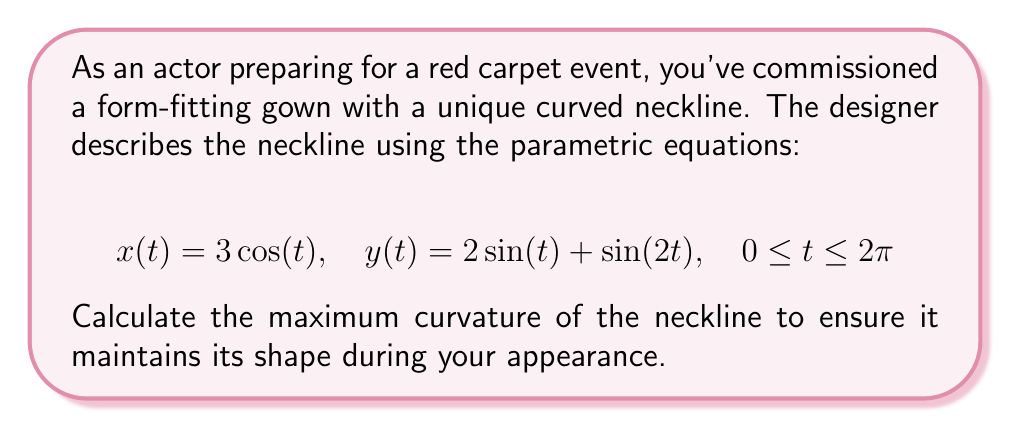Provide a solution to this math problem. To find the maximum curvature, we'll follow these steps:

1) The curvature formula for parametric equations is:

   $$\kappa = \frac{|x'y'' - y'x''|}{(x'^2 + y'^2)^{3/2}}$$

2) Calculate the first derivatives:
   $$x'(t) = -3\sin(t)$$
   $$y'(t) = 2\cos(t) + 2\cos(2t)$$

3) Calculate the second derivatives:
   $$x''(t) = -3\cos(t)$$
   $$y''(t) = -2\sin(t) - 4\sin(2t)$$

4) Substitute into the curvature formula:

   $$\kappa(t) = \frac{|-3\sin(t)(-2\sin(t) - 4\sin(2t)) - (2\cos(t) + 2\cos(2t))(-3\cos(t))|}{(9\sin^2(t) + (2\cos(t) + 2\cos(2t))^2)^{3/2}}$$

5) Simplify:

   $$\kappa(t) = \frac{|6\sin^2(t) + 12\sin(t)\sin(2t) + 6\cos^2(t) + 6\cos(t)\cos(2t)|}{(9\sin^2(t) + 4\cos^2(t) + 4\cos^2(2t) + 8\cos(t)\cos(2t))^{3/2}}$$

6) To find the maximum curvature, we need to find the maximum value of this function over the interval $[0, 2\pi]$. This is typically done numerically due to the complexity of the function.

7) Using numerical methods (which can be implemented in various software packages), we find that the maximum curvature occurs at approximately $t = 1.5708$ (or $\pi/2$).

8) The maximum curvature value is approximately 0.5.
Answer: 0.5 